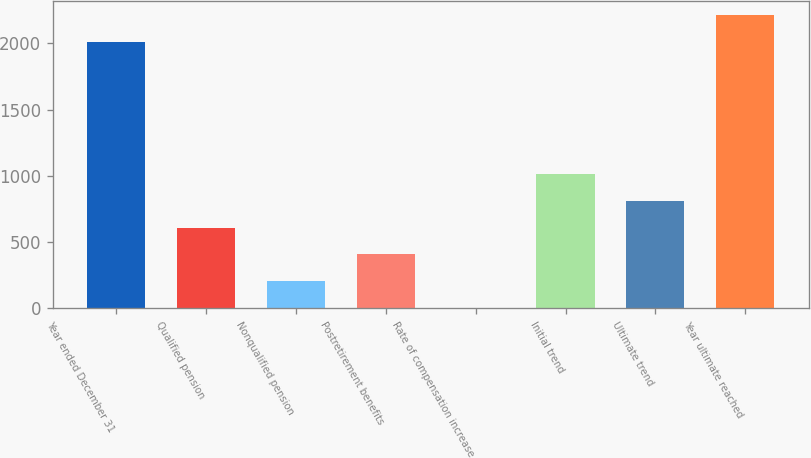Convert chart. <chart><loc_0><loc_0><loc_500><loc_500><bar_chart><fcel>Year ended December 31<fcel>Qualified pension<fcel>Nonqualified pension<fcel>Postretirement benefits<fcel>Rate of compensation increase<fcel>Initial trend<fcel>Ultimate trend<fcel>Year ultimate reached<nl><fcel>2011<fcel>608.5<fcel>205.5<fcel>407<fcel>4<fcel>1011.5<fcel>810<fcel>2212.5<nl></chart> 